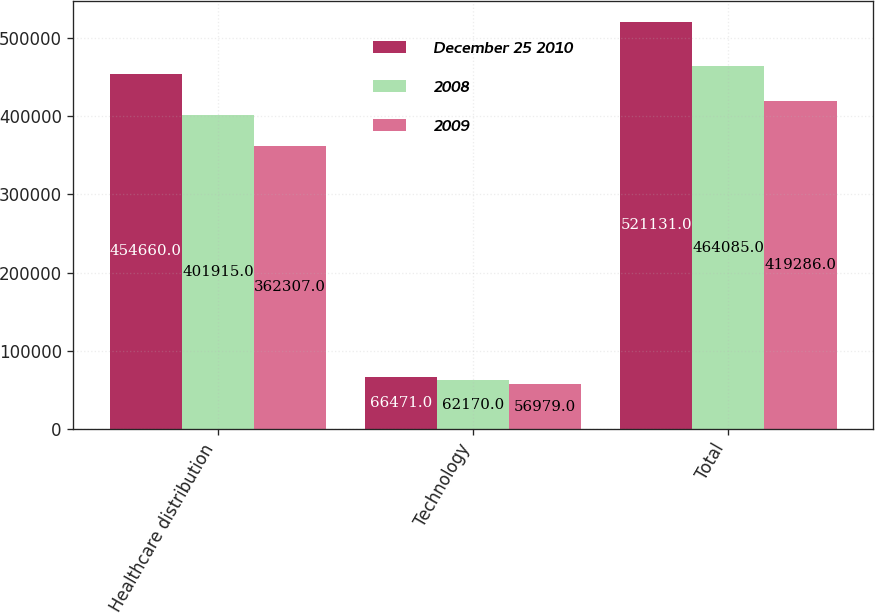Convert chart to OTSL. <chart><loc_0><loc_0><loc_500><loc_500><stacked_bar_chart><ecel><fcel>Healthcare distribution<fcel>Technology<fcel>Total<nl><fcel>December 25 2010<fcel>454660<fcel>66471<fcel>521131<nl><fcel>2008<fcel>401915<fcel>62170<fcel>464085<nl><fcel>2009<fcel>362307<fcel>56979<fcel>419286<nl></chart> 